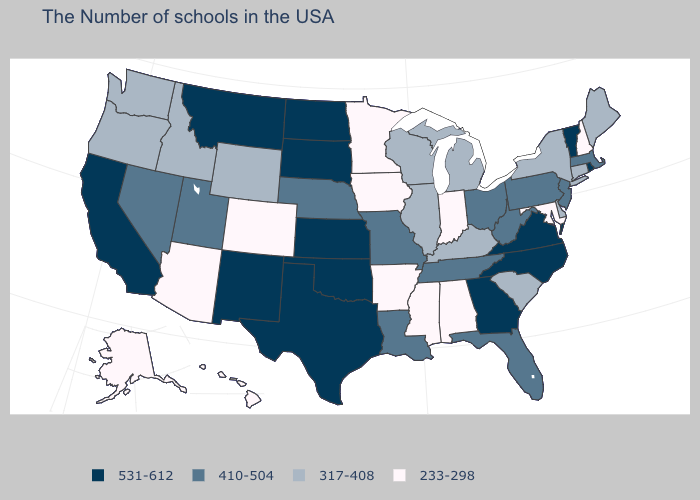Does the first symbol in the legend represent the smallest category?
Concise answer only. No. Does the first symbol in the legend represent the smallest category?
Give a very brief answer. No. What is the value of New Jersey?
Give a very brief answer. 410-504. Which states have the lowest value in the USA?
Answer briefly. New Hampshire, Maryland, Indiana, Alabama, Mississippi, Arkansas, Minnesota, Iowa, Colorado, Arizona, Alaska, Hawaii. Name the states that have a value in the range 233-298?
Write a very short answer. New Hampshire, Maryland, Indiana, Alabama, Mississippi, Arkansas, Minnesota, Iowa, Colorado, Arizona, Alaska, Hawaii. Among the states that border North Dakota , which have the highest value?
Write a very short answer. South Dakota, Montana. How many symbols are there in the legend?
Be succinct. 4. What is the value of Oklahoma?
Give a very brief answer. 531-612. Name the states that have a value in the range 317-408?
Give a very brief answer. Maine, Connecticut, New York, Delaware, South Carolina, Michigan, Kentucky, Wisconsin, Illinois, Wyoming, Idaho, Washington, Oregon. What is the lowest value in the MidWest?
Keep it brief. 233-298. How many symbols are there in the legend?
Short answer required. 4. How many symbols are there in the legend?
Concise answer only. 4. Does Wyoming have the same value as South Carolina?
Keep it brief. Yes. Among the states that border Missouri , which have the highest value?
Short answer required. Kansas, Oklahoma. 